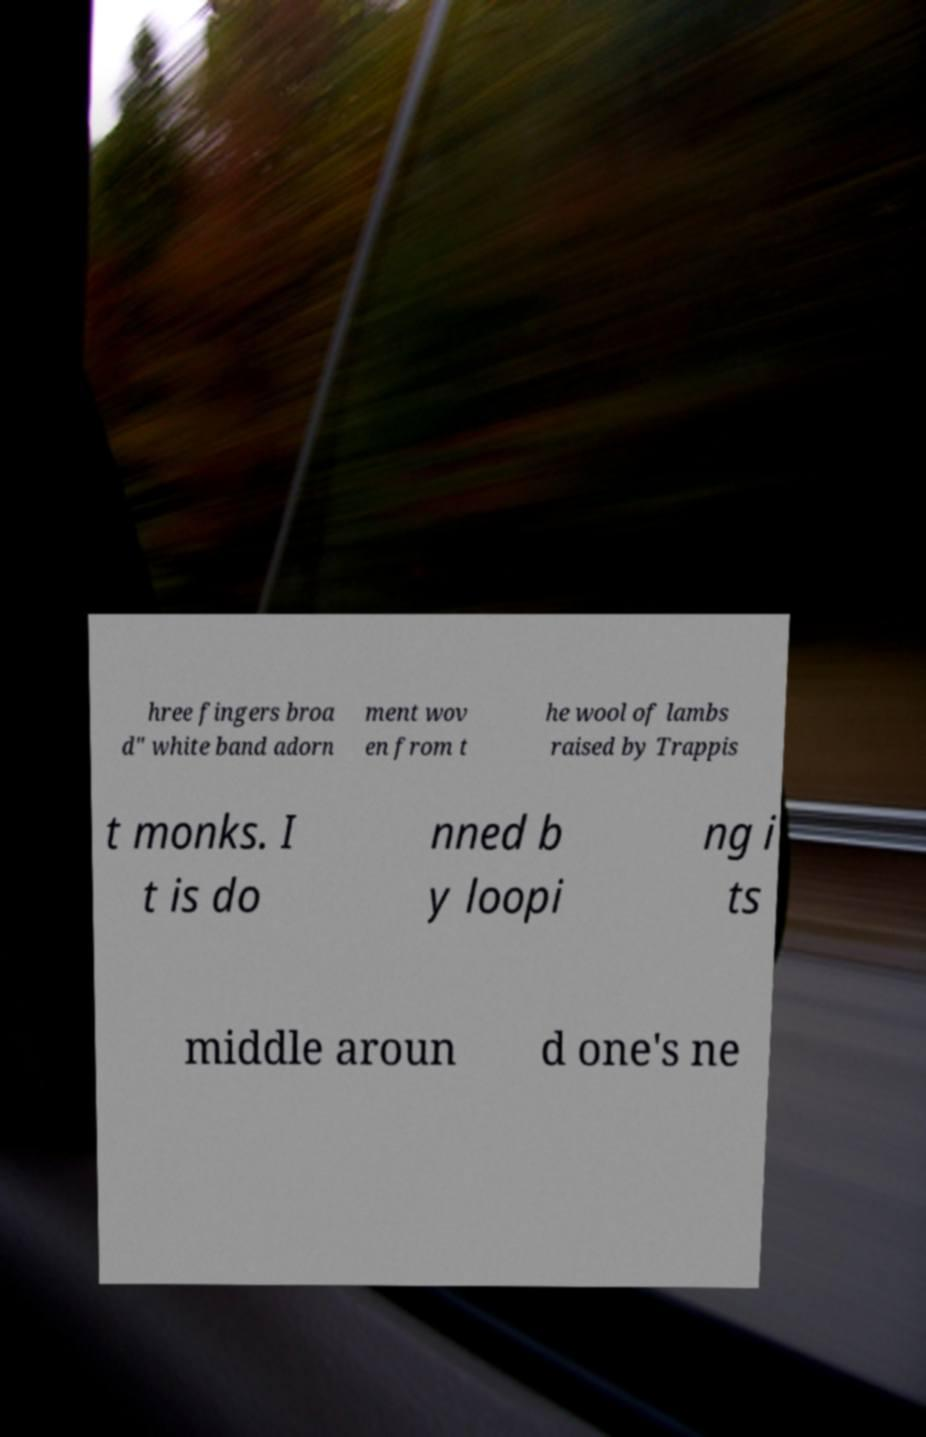What messages or text are displayed in this image? I need them in a readable, typed format. hree fingers broa d" white band adorn ment wov en from t he wool of lambs raised by Trappis t monks. I t is do nned b y loopi ng i ts middle aroun d one's ne 